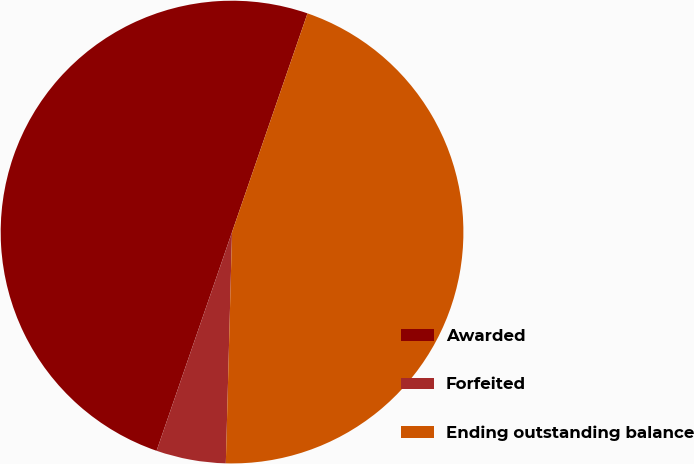Convert chart to OTSL. <chart><loc_0><loc_0><loc_500><loc_500><pie_chart><fcel>Awarded<fcel>Forfeited<fcel>Ending outstanding balance<nl><fcel>50.0%<fcel>4.86%<fcel>45.14%<nl></chart> 